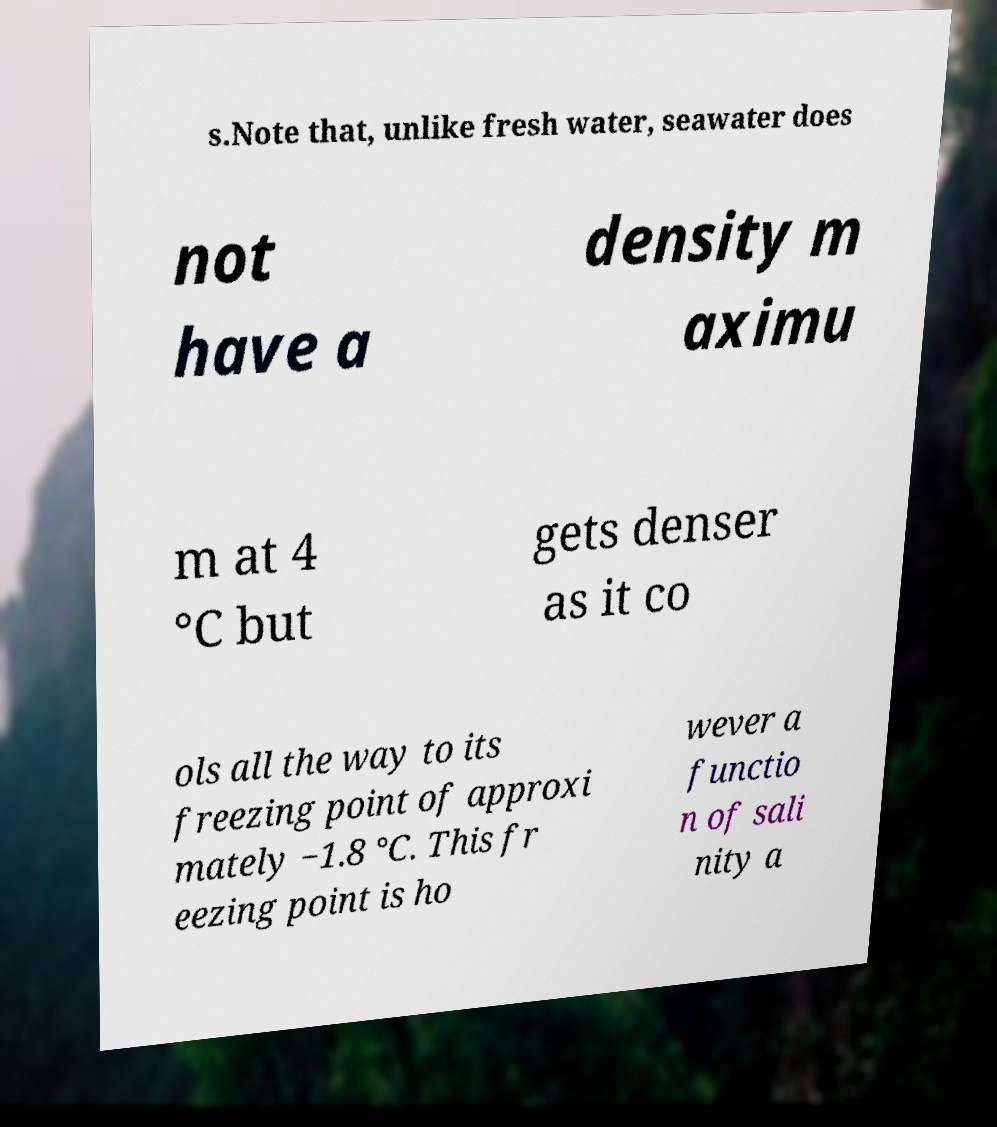For documentation purposes, I need the text within this image transcribed. Could you provide that? s.Note that, unlike fresh water, seawater does not have a density m aximu m at 4 °C but gets denser as it co ols all the way to its freezing point of approxi mately −1.8 °C. This fr eezing point is ho wever a functio n of sali nity a 